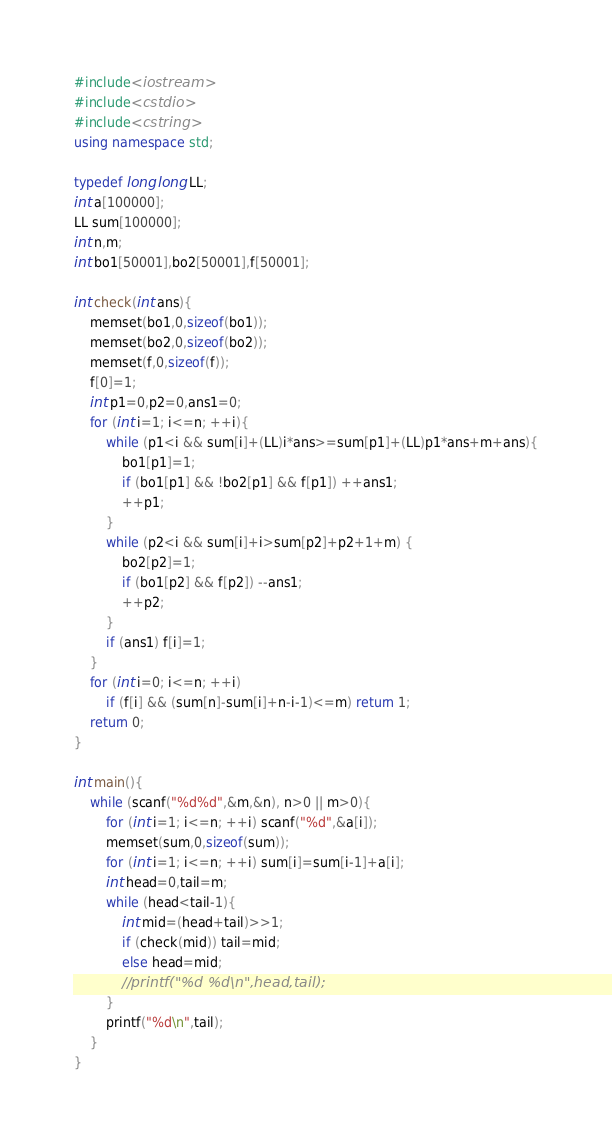<code> <loc_0><loc_0><loc_500><loc_500><_C++_>#include<iostream>
#include<cstdio>
#include<cstring>
using namespace std;

typedef long long LL;
int a[100000];
LL sum[100000];
int n,m;
int bo1[50001],bo2[50001],f[50001];

int check(int ans){
	memset(bo1,0,sizeof(bo1));
	memset(bo2,0,sizeof(bo2));
	memset(f,0,sizeof(f));
	f[0]=1;
	int p1=0,p2=0,ans1=0;
	for (int i=1; i<=n; ++i){
		while (p1<i && sum[i]+(LL)i*ans>=sum[p1]+(LL)p1*ans+m+ans){
			bo1[p1]=1;
			if (bo1[p1] && !bo2[p1] && f[p1]) ++ans1; 
			++p1;
		}
		while (p2<i && sum[i]+i>sum[p2]+p2+1+m) {
			bo2[p2]=1;
			if (bo1[p2] && f[p2]) --ans1;
			++p2;
		}
		if (ans1) f[i]=1;
	}
	for (int i=0; i<=n; ++i)
		if (f[i] && (sum[n]-sum[i]+n-i-1)<=m) return 1;
	return 0;
}

int main(){
	while (scanf("%d%d",&m,&n), n>0 || m>0){
		for (int i=1; i<=n; ++i) scanf("%d",&a[i]);
		memset(sum,0,sizeof(sum));
		for (int i=1; i<=n; ++i) sum[i]=sum[i-1]+a[i];
		int head=0,tail=m;
		while (head<tail-1){
			int mid=(head+tail)>>1;
			if (check(mid)) tail=mid;
			else head=mid;
			//printf("%d %d\n",head,tail);
		}
		printf("%d\n",tail);
	}
}</code> 